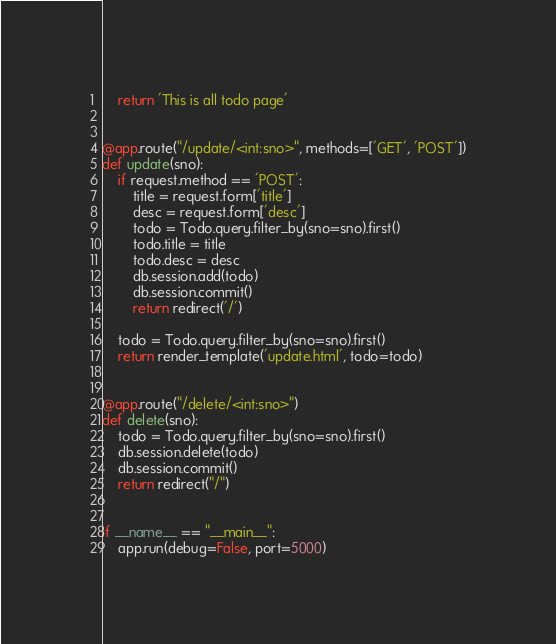Convert code to text. <code><loc_0><loc_0><loc_500><loc_500><_Python_>    return 'This is all todo page'


@app.route("/update/<int:sno>", methods=['GET', 'POST'])
def update(sno):
    if request.method == 'POST':
        title = request.form['title']
        desc = request.form['desc']
        todo = Todo.query.filter_by(sno=sno).first()
        todo.title = title
        todo.desc = desc
        db.session.add(todo)
        db.session.commit()
        return redirect('/')

    todo = Todo.query.filter_by(sno=sno).first()
    return render_template('update.html', todo=todo)


@app.route("/delete/<int:sno>")
def delete(sno):
    todo = Todo.query.filter_by(sno=sno).first()
    db.session.delete(todo)
    db.session.commit()
    return redirect("/")


if __name__ == "__main__":
    app.run(debug=False, port=5000)
</code> 